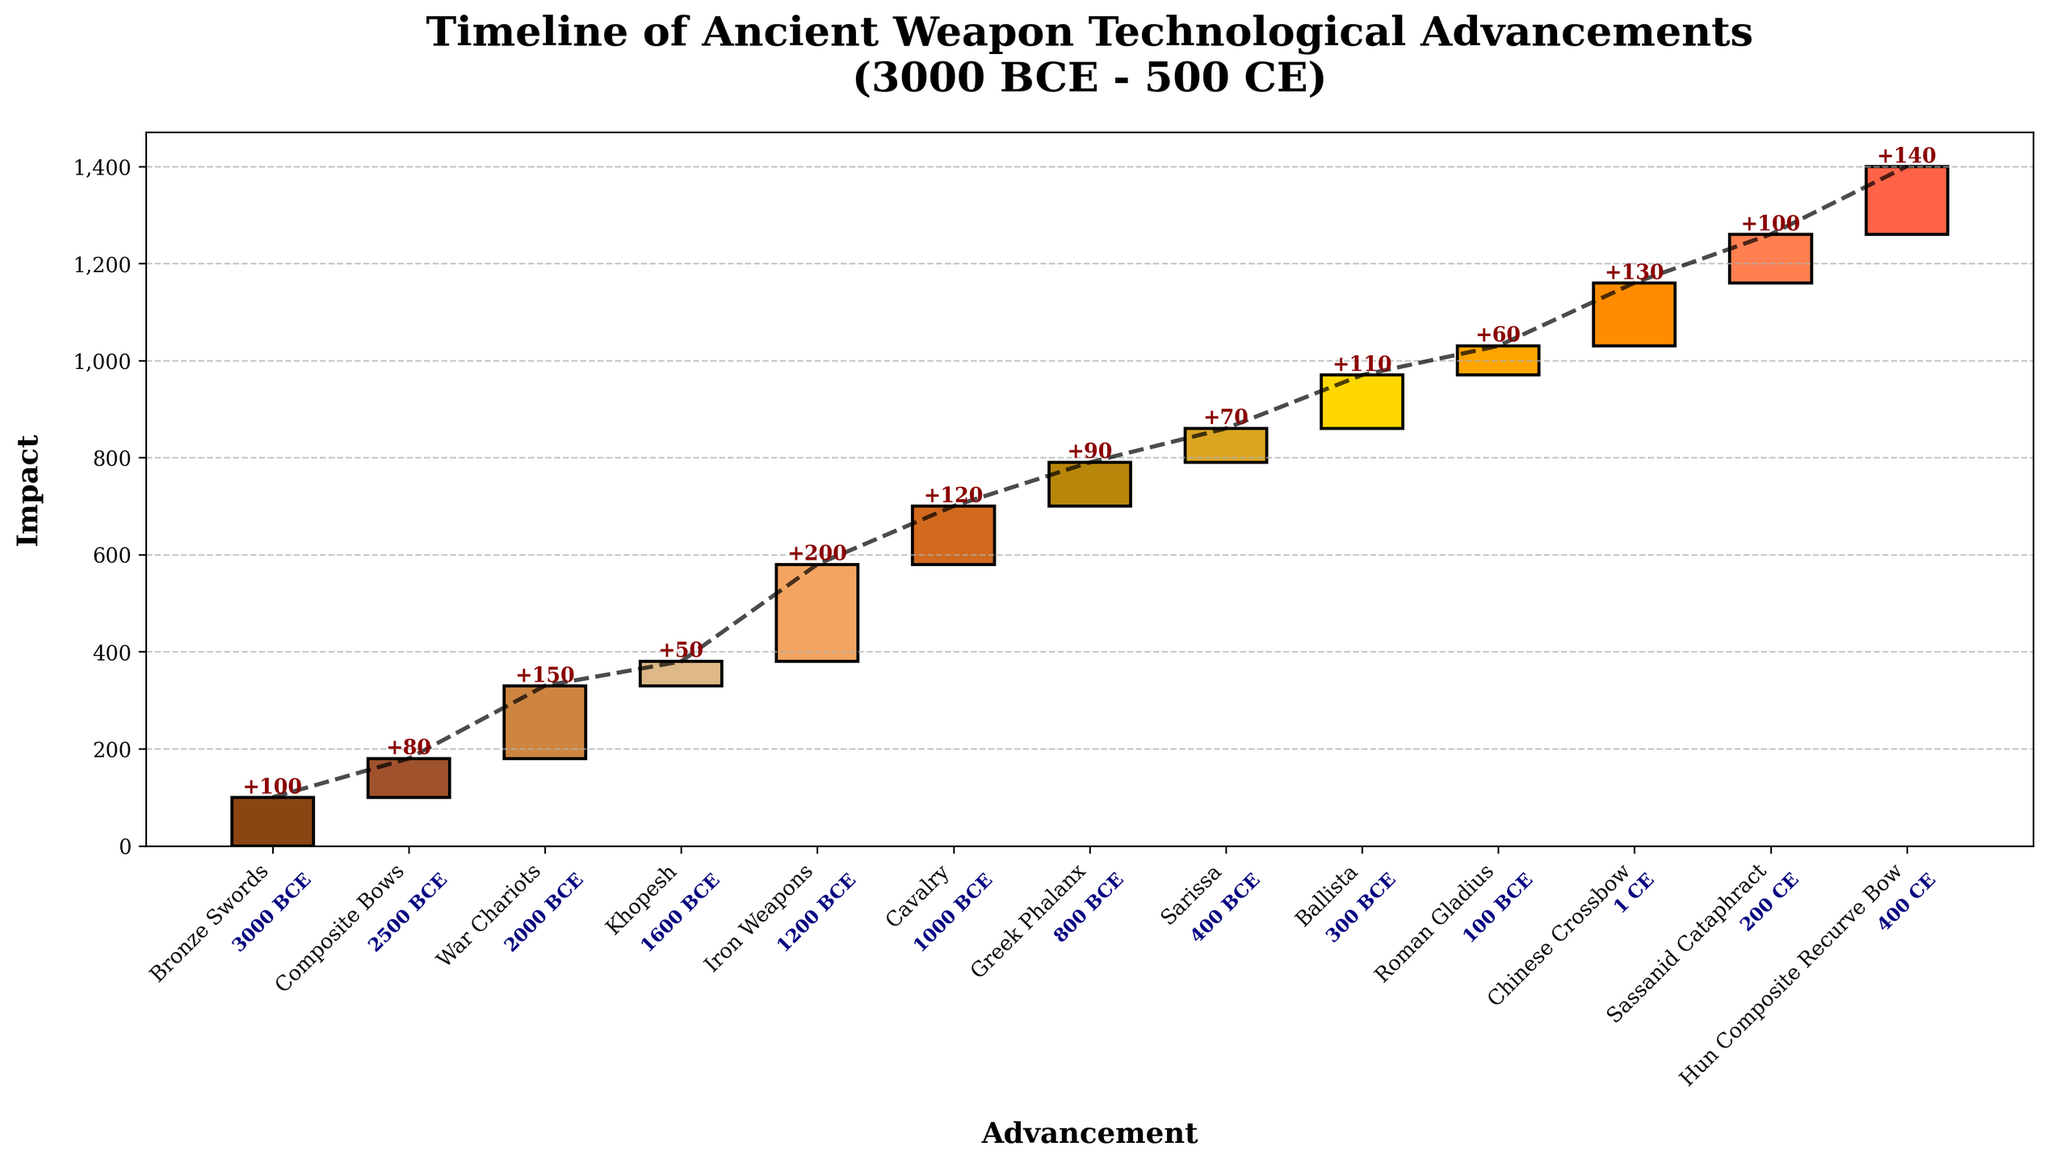What's the total impact from 3000 BCE to 500 CE? Sum the impacts of all advancements: 100 + 80 + 150 + 50 + 200 + 120 + 90 + 70 + 110 + 60 + 130 + 100 + 140 = 1,400
Answer: 1,400 Which advancement had the highest impact? Look at the impact values and find the highest one. The Iron Weapons introduced in 1200 BCE had the highest impact of 200
Answer: Iron Weapons How many advancements occurred before 1000 BCE? Check the timeline and count the advancements dated before 1000 BCE: Bronze Swords, Composite Bows, War Chariots, Khopesh, Iron Weapons. There are 5 advancements before 1000 BCE
Answer: 5 What is the cumulative impact immediately after the introduction of the Chinese Crossbow? The Chinese Crossbow was introduced in 1 CE. Calculate cumulative impact up to this point: 100 + 80 + 150 + 50 + 200 + 120 + 90 + 70 + 110 + 60 + 130 = 1,160
Answer: 1,160 What is the average impact of the advancements from the Greek Phalanx to the Ballista? Calculate the average impact of Greek Phalanx, Sarissa, and Ballista: (90 + 70 + 110) / 3 = 270 / 3 = 90
Answer: 90 Which periods had the shortest and the longest time gaps between advancements? Look at the timeline and intervals between advancements: 
Shortest gap is between 400 CE -300 CE = 100 years.
Longest gap is between 1600 BCE - 2000 BCE = 400 years.
Answer: Shortest: 100 years, Longest: 400 years What is the increase in cumulative impact from Roman Gladius to the Hun Composite Recurve Bow? Calculate cumulative impact at Roman Gladius (1,040) and at Hun Composite Recurve Bow (1,400): 1,400 - 1,040 = 360
Answer: 360 Which advancement occurred halfway through the timeline? The total timeline spans from 3000 BCE to 500 CE. The midpoint is around 800 BCE. Look for the advancement at or near this date: Greek Phalanx (800 BCE)
Answer: Greek Phalanx How does the impact of the Khopesh compare to that of the Ballista? Compare their impacts: Khopesh has an impact of 50 and Ballista has an impact of 110. Ballista has greater impact.
Answer: Ballista has greater impact 